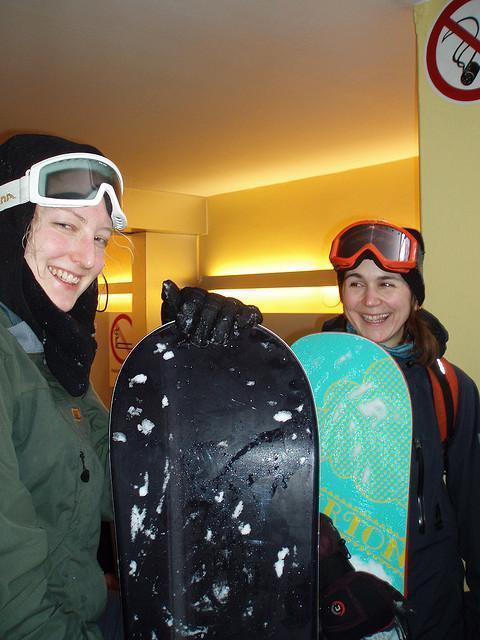How many people are there?
Give a very brief answer. 2. How many people are in the picture?
Give a very brief answer. 2. How many snowboards are in the picture?
Give a very brief answer. 2. How many bowls are in the picture?
Give a very brief answer. 0. 